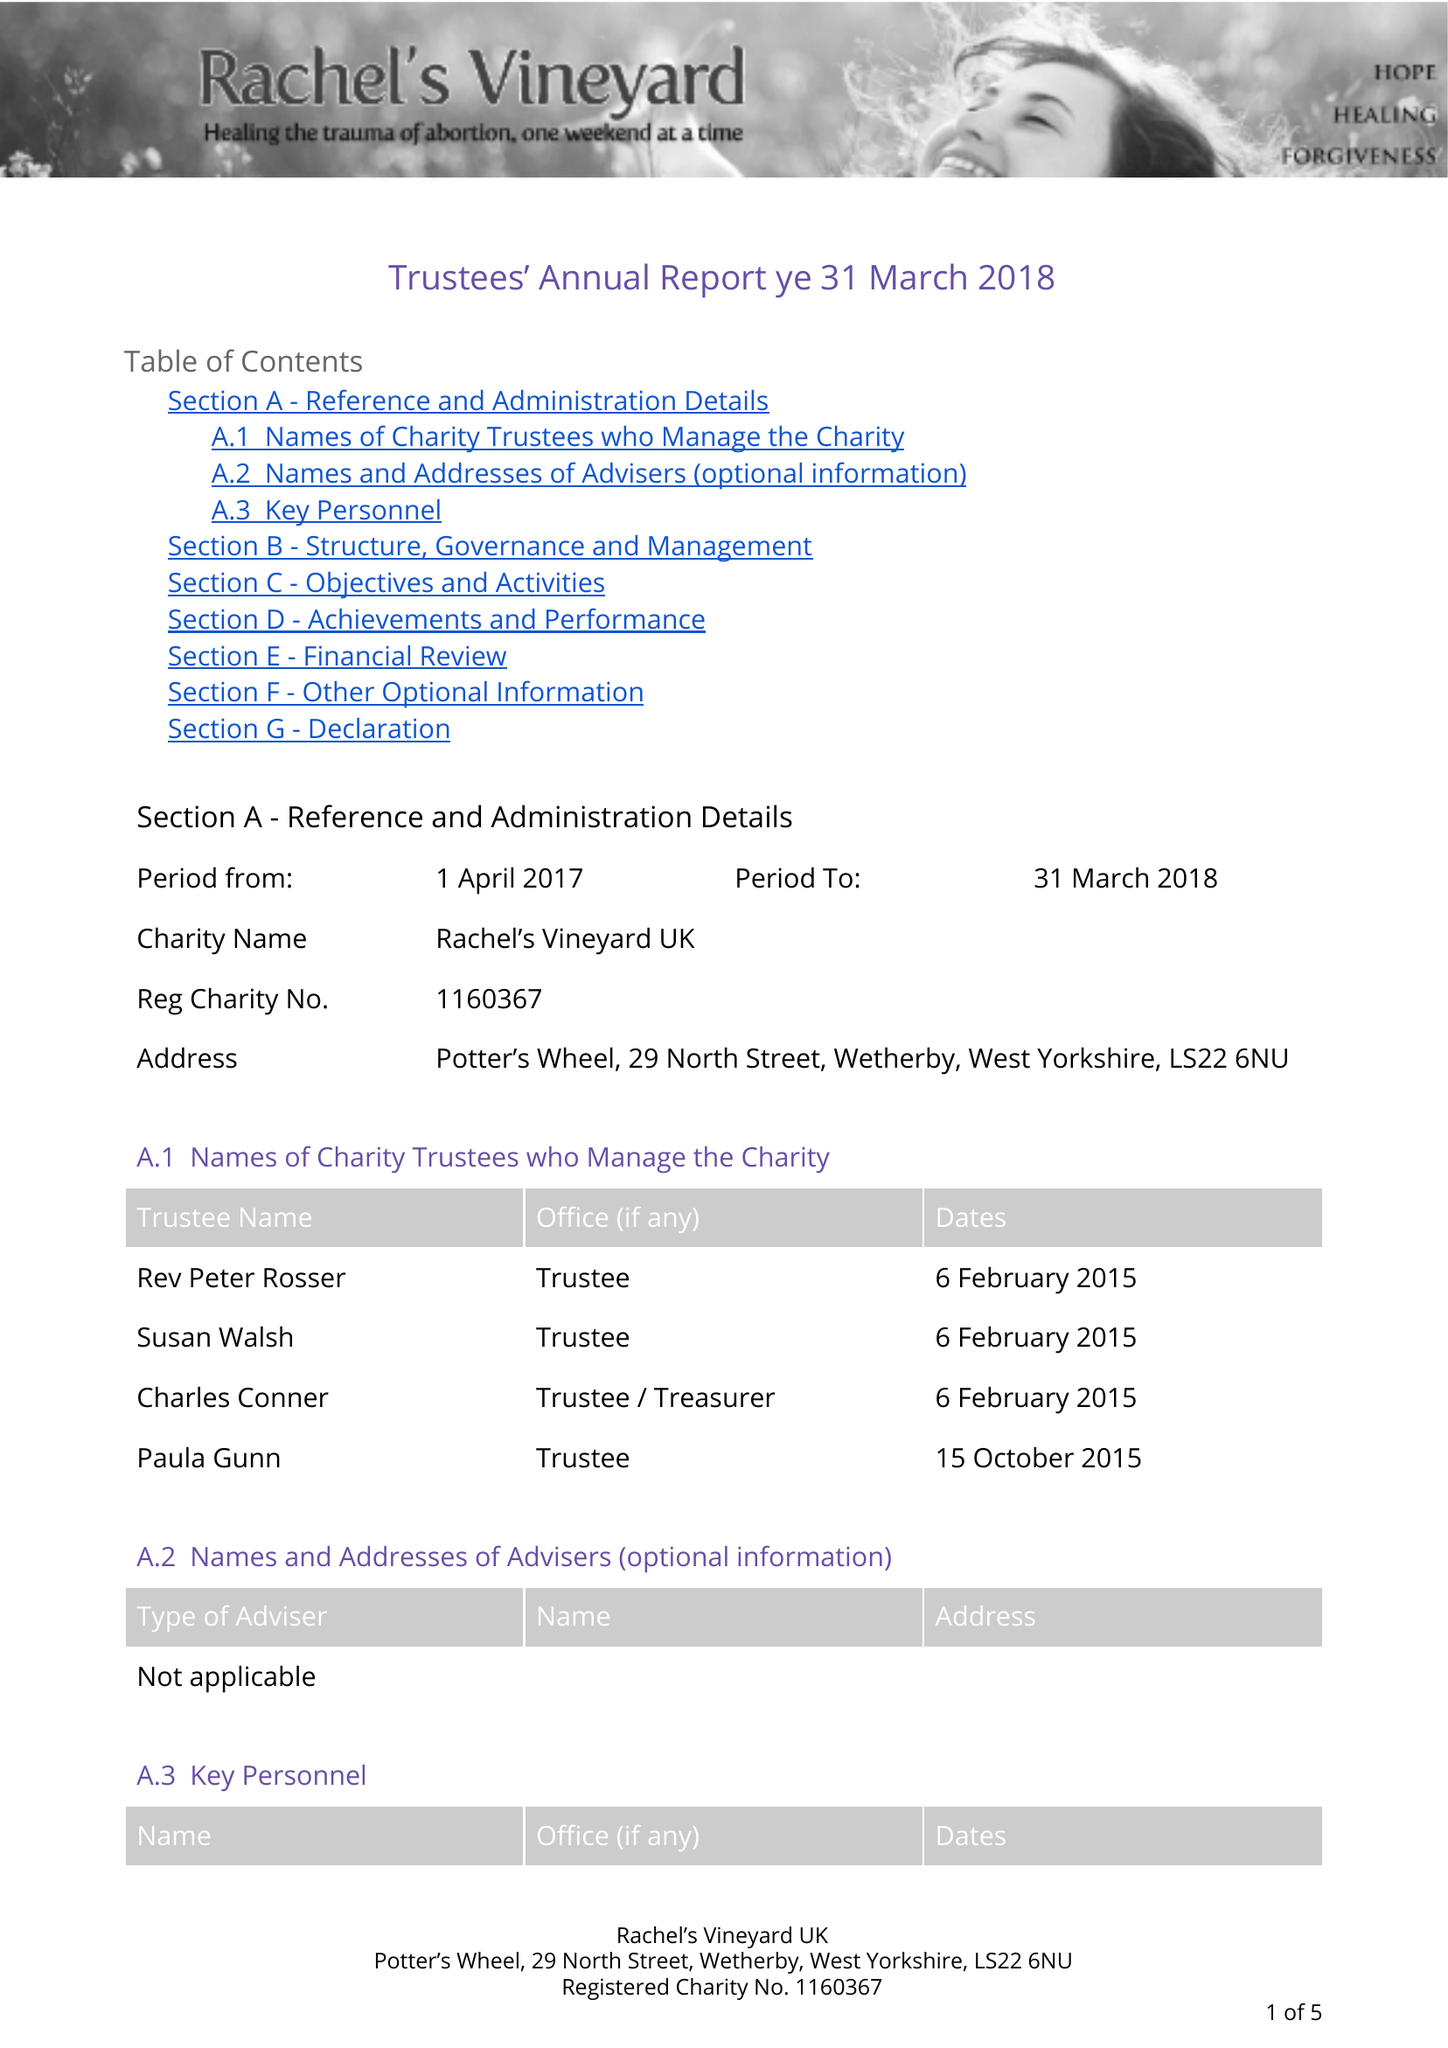What is the value for the income_annually_in_british_pounds?
Answer the question using a single word or phrase. 12805.00 